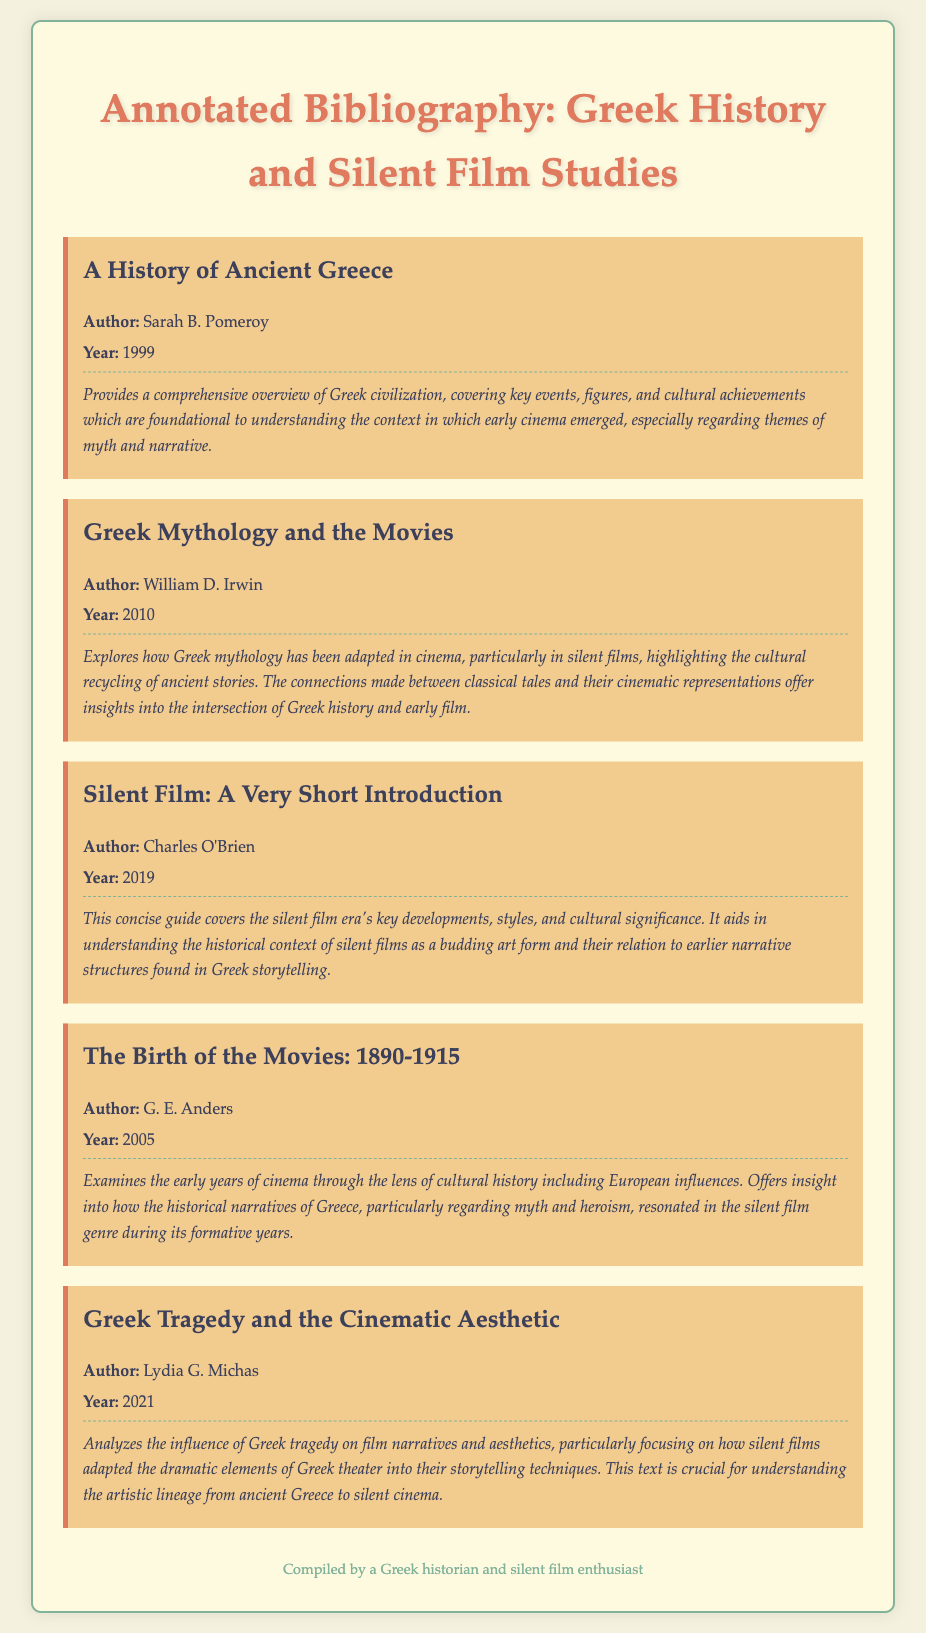What is the title of the first book listed? The title is the name of the book and the first book listed is "A History of Ancient Greece."
Answer: A History of Ancient Greece Who is the author of "Greek Mythology and the Movies"? The author is the individual who wrote the book, and for "Greek Mythology and the Movies," it is William D. Irwin.
Answer: William D. Irwin In what year was "Silent Film: A Very Short Introduction" published? The year is a specific detail provided for each book, and "Silent Film: A Very Short Introduction" was published in 2019.
Answer: 2019 Which book discusses the influence of Greek tragedy on film? This requires understanding the relevance notes, and the book that analyzes Greek tragedy's influence on film narratives is "Greek Tragedy and the Cinematic Aesthetic."
Answer: Greek Tragedy and the Cinematic Aesthetic What subject does "The Birth of the Movies: 1890-1915" explore? The book's title and relevance provide insights into its focus, which examines the early years of cinema through cultural history.
Answer: Early years of cinema Which book emphasizes the connection between ancient stories and cinema? The reasoning involves piecing together details from the relevance notes, and the book highlighting this connection is "Greek Mythology and the Movies."
Answer: Greek Mythology and the Movies 